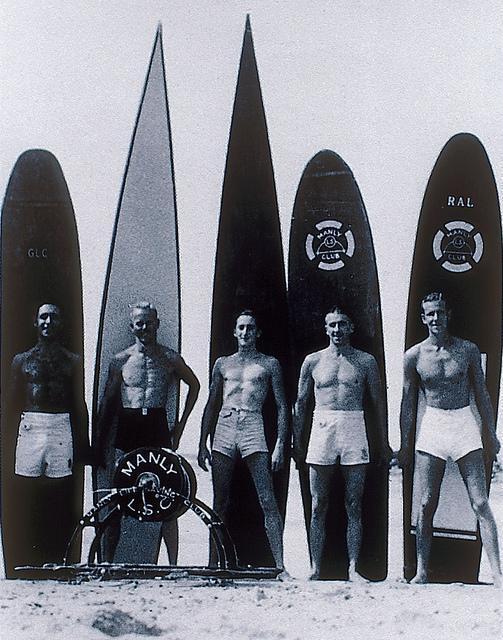How many men are in this picture?
Give a very brief answer. 5. How many people are there?
Give a very brief answer. 5. How many surfboards are visible?
Give a very brief answer. 5. 